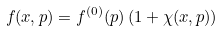Convert formula to latex. <formula><loc_0><loc_0><loc_500><loc_500>f ( x , p ) = f ^ { ( 0 ) } { ( p ) } \left ( 1 + \chi ( x , p ) \right )</formula> 